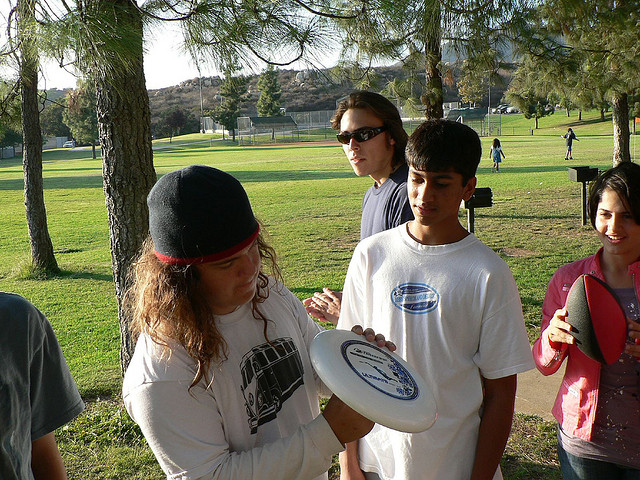<image>What color is the striped shirt? There is no striped shirt in the image. What color is the striped shirt? There is no striped shirt in the image. 